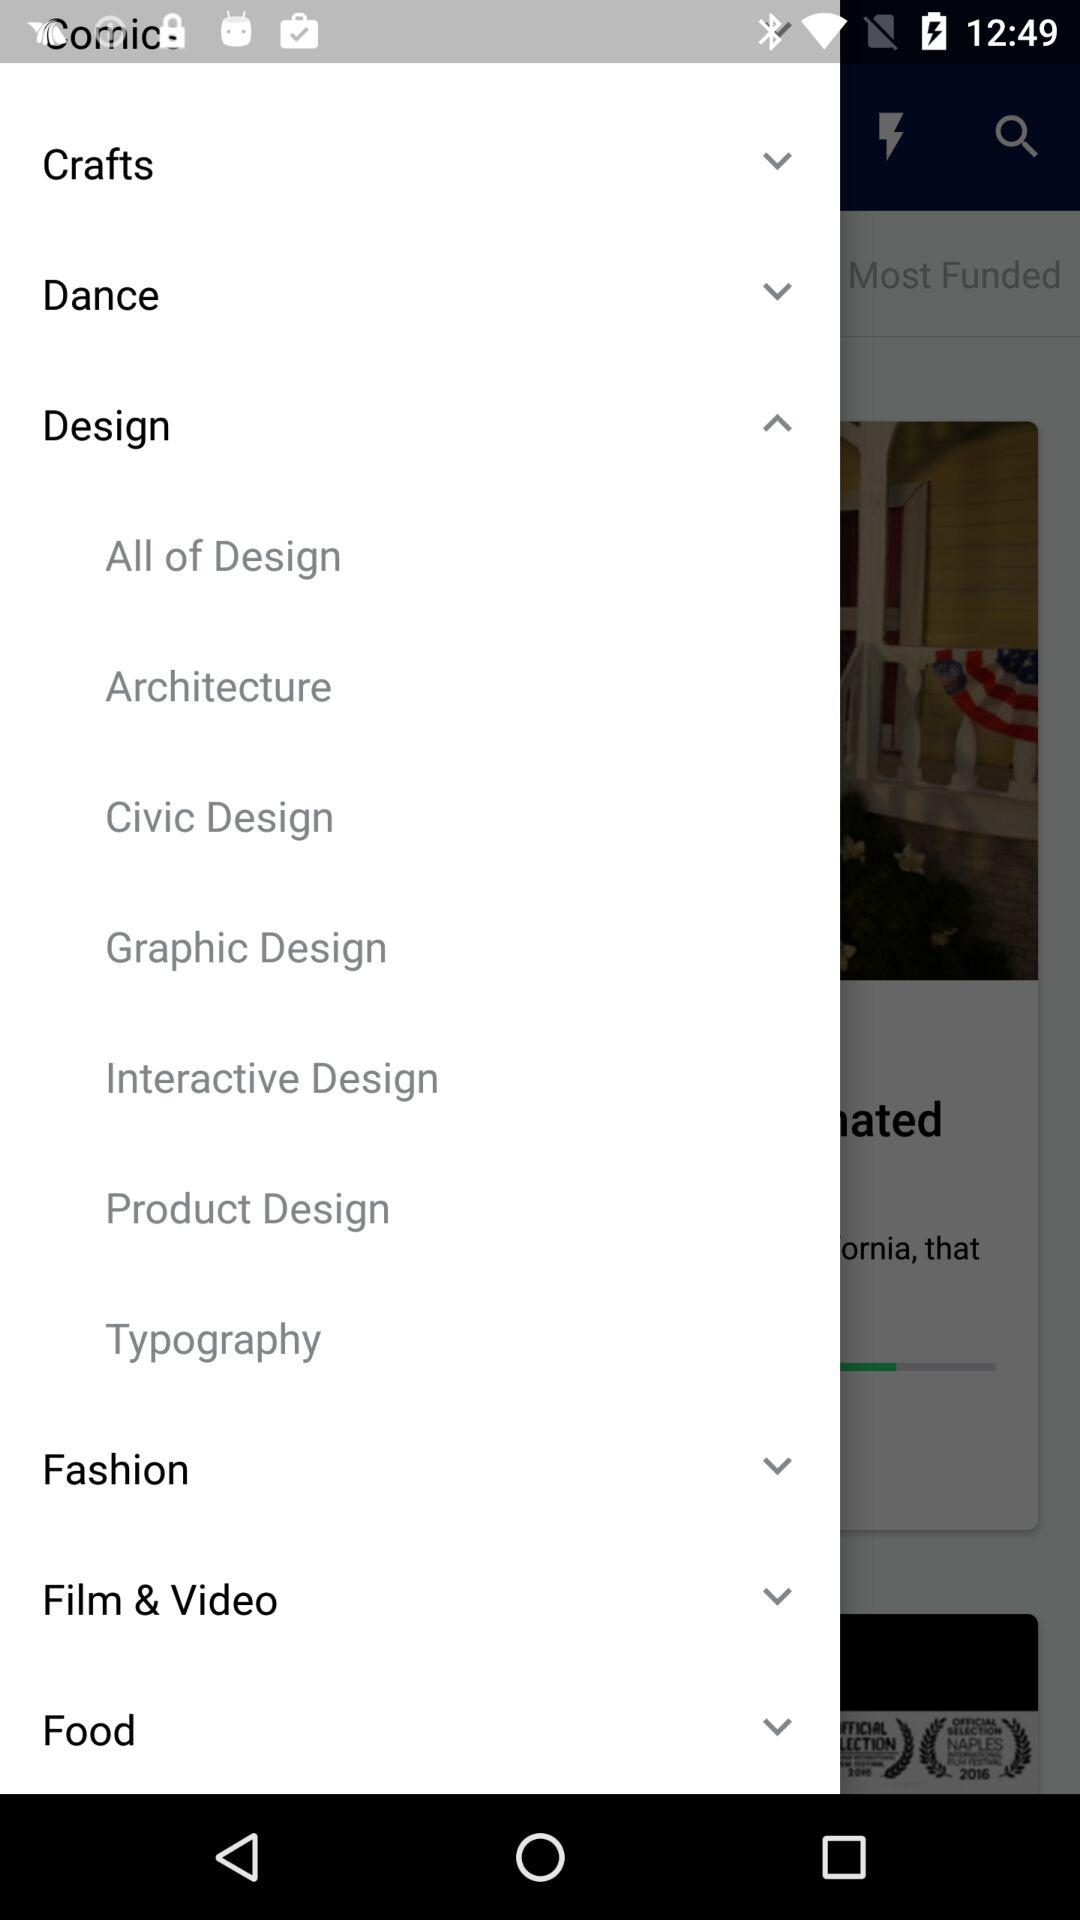What are the various items in "Design"? The various items in "Design" are "All of Design", "Architecture", "Civic Design", "Graphic Design", "Interactive Design", "Product Design" and "Typography". 